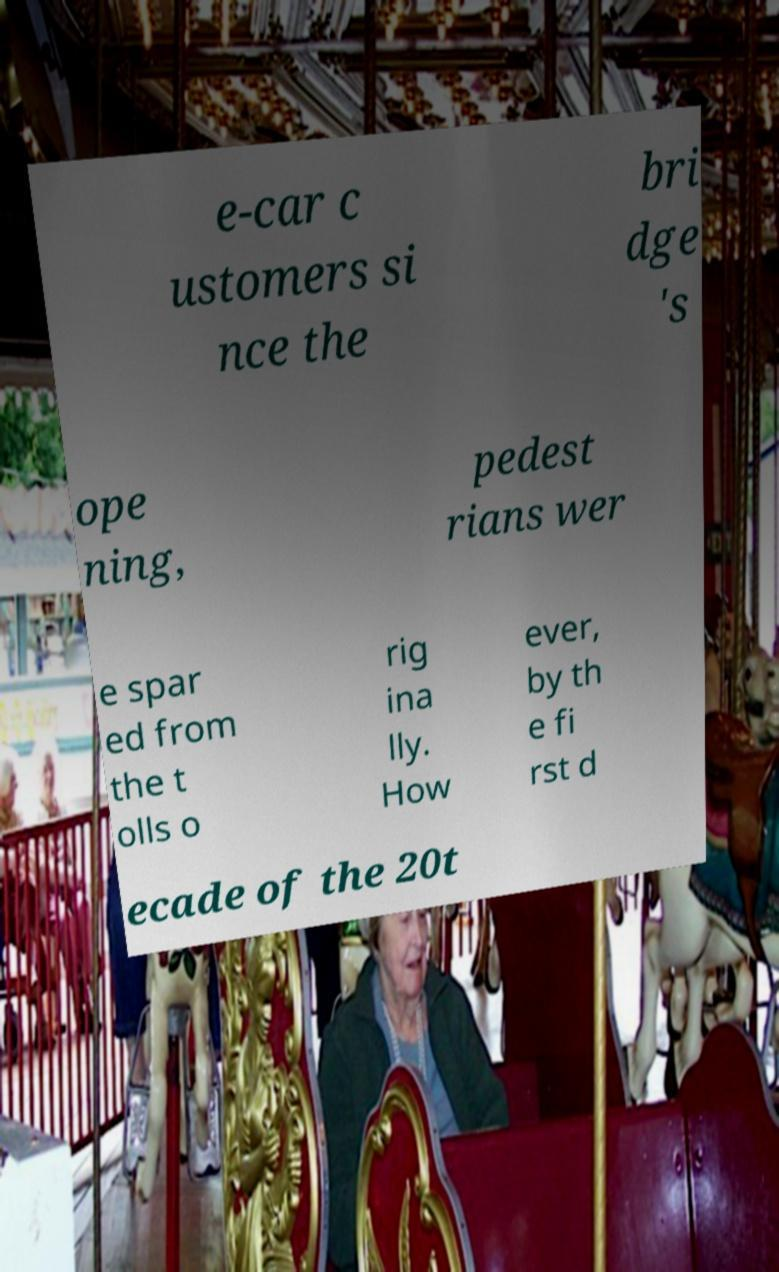Please read and relay the text visible in this image. What does it say? e-car c ustomers si nce the bri dge 's ope ning, pedest rians wer e spar ed from the t olls o rig ina lly. How ever, by th e fi rst d ecade of the 20t 